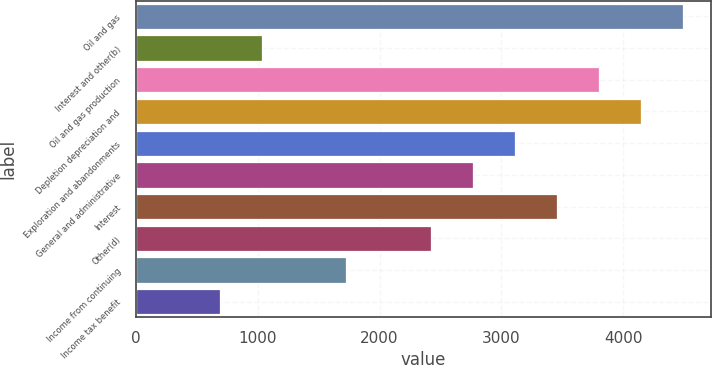Convert chart. <chart><loc_0><loc_0><loc_500><loc_500><bar_chart><fcel>Oil and gas<fcel>Interest and other(b)<fcel>Oil and gas production<fcel>Depletion depreciation and<fcel>Exploration and abandonments<fcel>General and administrative<fcel>Interest<fcel>Other(d)<fcel>Income from continuing<fcel>Income tax benefit<nl><fcel>4491.64<fcel>1036.64<fcel>3800.64<fcel>4146.14<fcel>3109.64<fcel>2764.14<fcel>3455.14<fcel>2418.64<fcel>1727.64<fcel>691.14<nl></chart> 